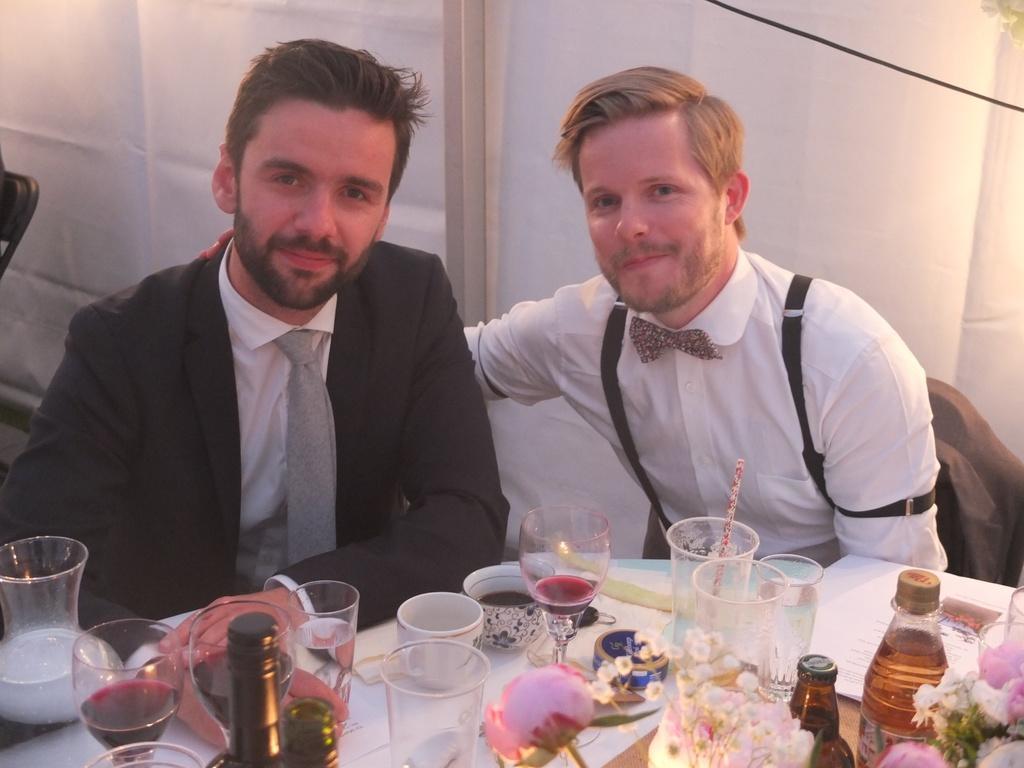Describe this image in one or two sentences. In this image I can see the person with black, white and ash color dress. In-front of the person I can see the bottles, glasses, cups and flowers on the table. And there is a white background. 